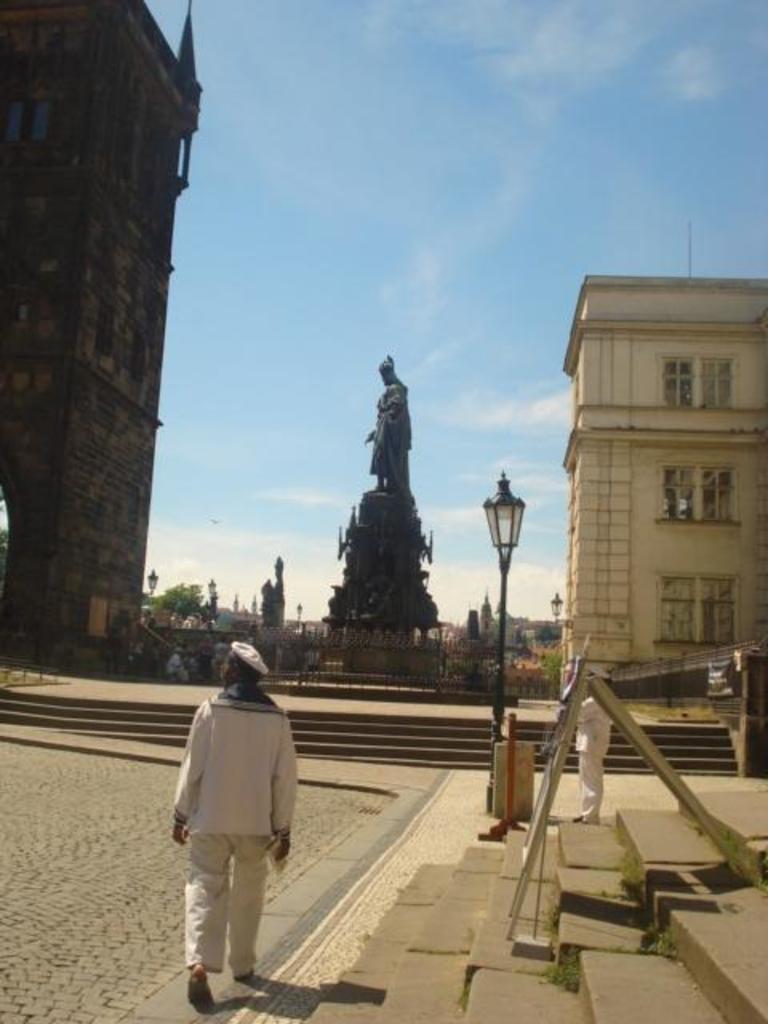In one or two sentences, can you explain what this image depicts? In this image we can see the building on the left side and the right side as well. Here we can see the statue in between the buildings. Here we can see the metal fence around the statue. Here we can see a man walking on the road. Here we can see the staircase on the right side. Here we can see the decorative light pole. This is a sky with clouds. 